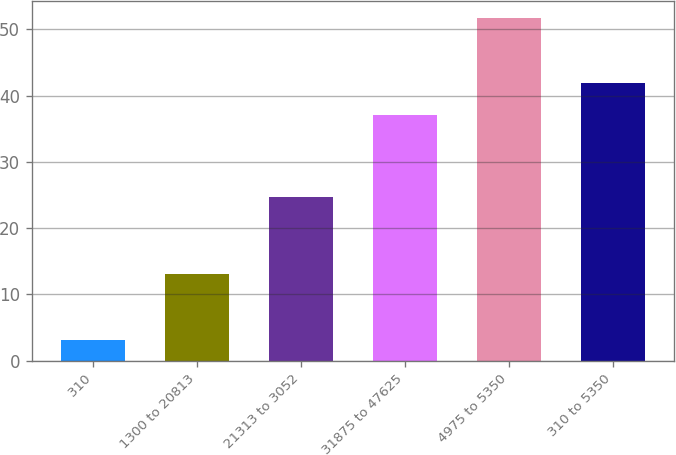Convert chart to OTSL. <chart><loc_0><loc_0><loc_500><loc_500><bar_chart><fcel>310<fcel>1300 to 20813<fcel>21313 to 3052<fcel>31875 to 47625<fcel>4975 to 5350<fcel>310 to 5350<nl><fcel>3.1<fcel>13.13<fcel>24.72<fcel>37.09<fcel>51.71<fcel>41.95<nl></chart> 